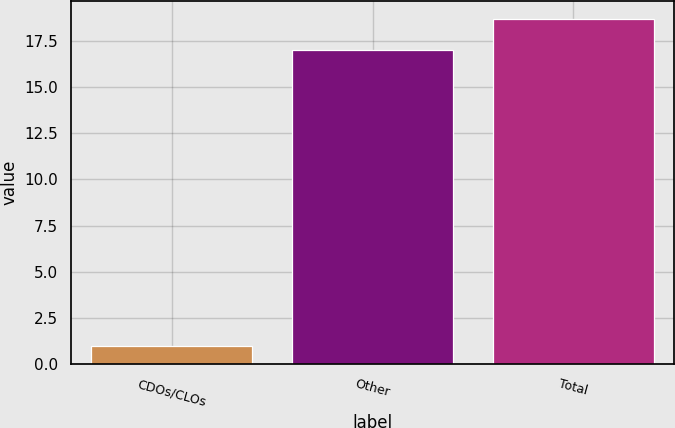Convert chart. <chart><loc_0><loc_0><loc_500><loc_500><bar_chart><fcel>CDOs/CLOs<fcel>Other<fcel>Total<nl><fcel>1<fcel>17<fcel>18.7<nl></chart> 